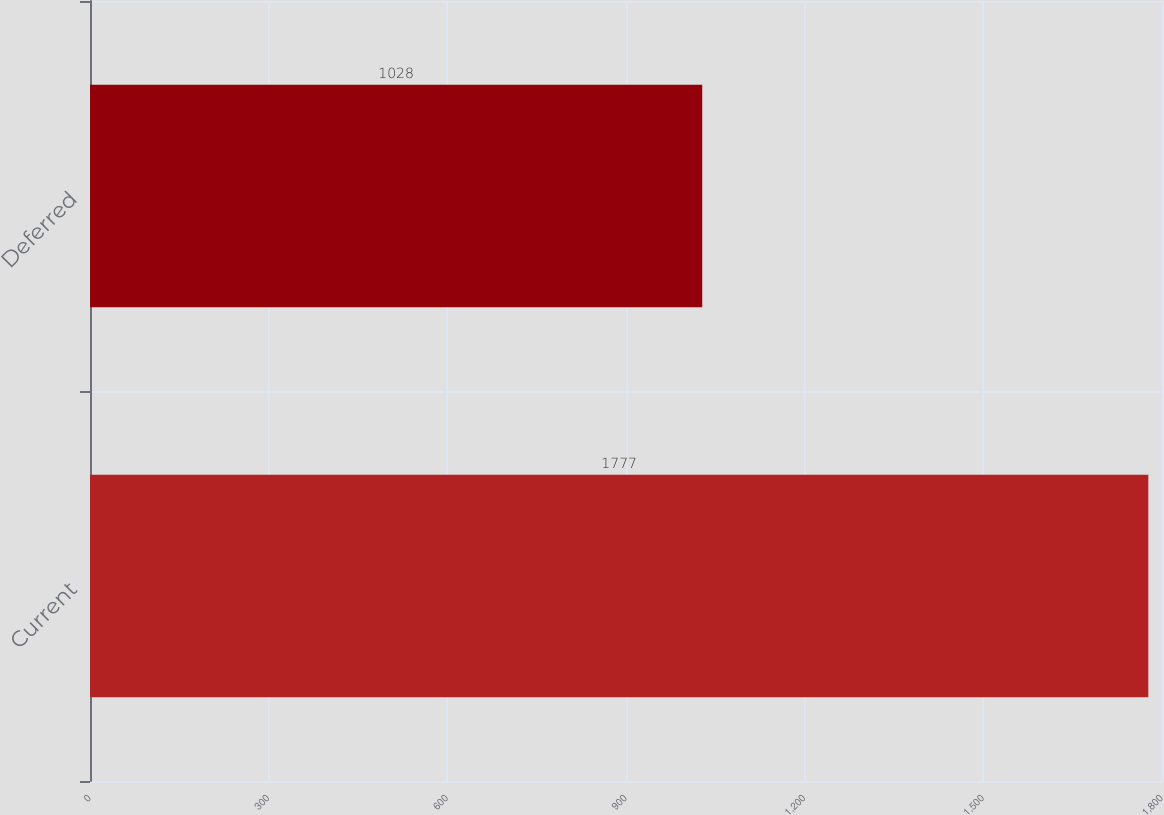Convert chart. <chart><loc_0><loc_0><loc_500><loc_500><bar_chart><fcel>Current<fcel>Deferred<nl><fcel>1777<fcel>1028<nl></chart> 